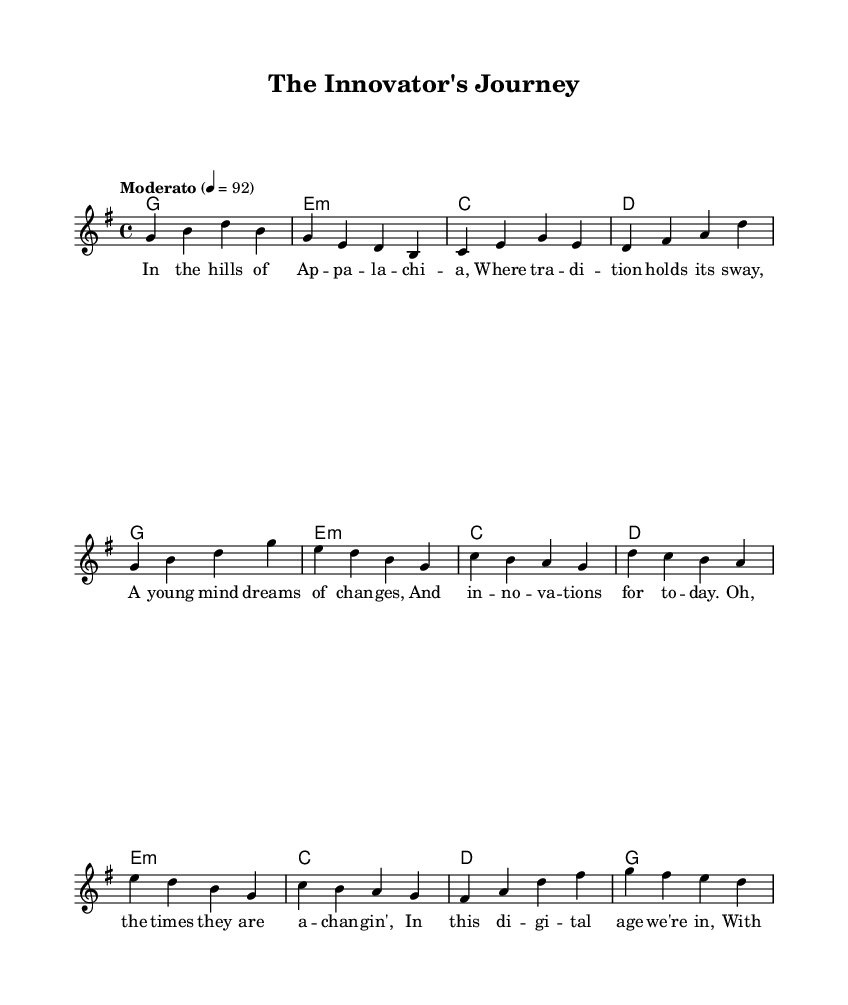What is the key signature of this music? The key signature indicates that this piece is in G major, which has one sharp (F#).
Answer: G major What is the time signature of this piece? The time signature is indicated at the beginning of the score as 4/4, meaning there are four beats in a measure and a quarter note gets one beat.
Answer: 4/4 What is the tempo marking for this music? The tempo marking is "Moderato," which indicates a moderate pace, specifically set at 92 beats per minute.
Answer: Moderato How many verses are there in the lyrics? The lyrics include two distinct sections identified as the verse and the chorus, plus a bridge, making it a total of three sections.
Answer: Three What themes are explored in the lyrics? The lyrics discuss themes of innovation and change, contrasting traditional values with modern technological advancements.
Answer: Innovation and change How is the structure of the song organized? The song follows a common folk structure with a verse, chorus, and bridge, illustrating a narrative while connecting ideas of the past to the future.
Answer: Verse, chorus, bridge What instrument is primarily featured in the score? The score features a staff intended for melody, indicating that a melodic instrument, such as a voice or a fiddle, is primarily highlighted.
Answer: Voice 